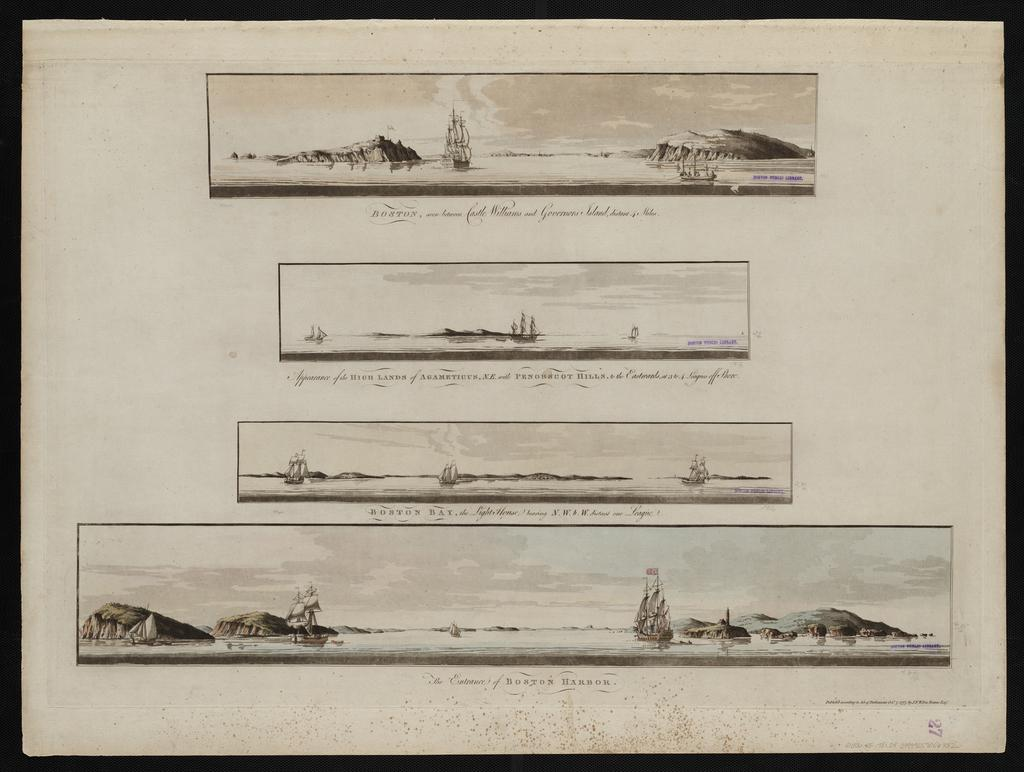What is present in the picture? There is a poster in the picture. What can be found on the poster? The poster contains images and text. Can you see a tiger hiding behind the jar in the image? There is no tiger or jar present in the image; it only features a poster with images and text. 